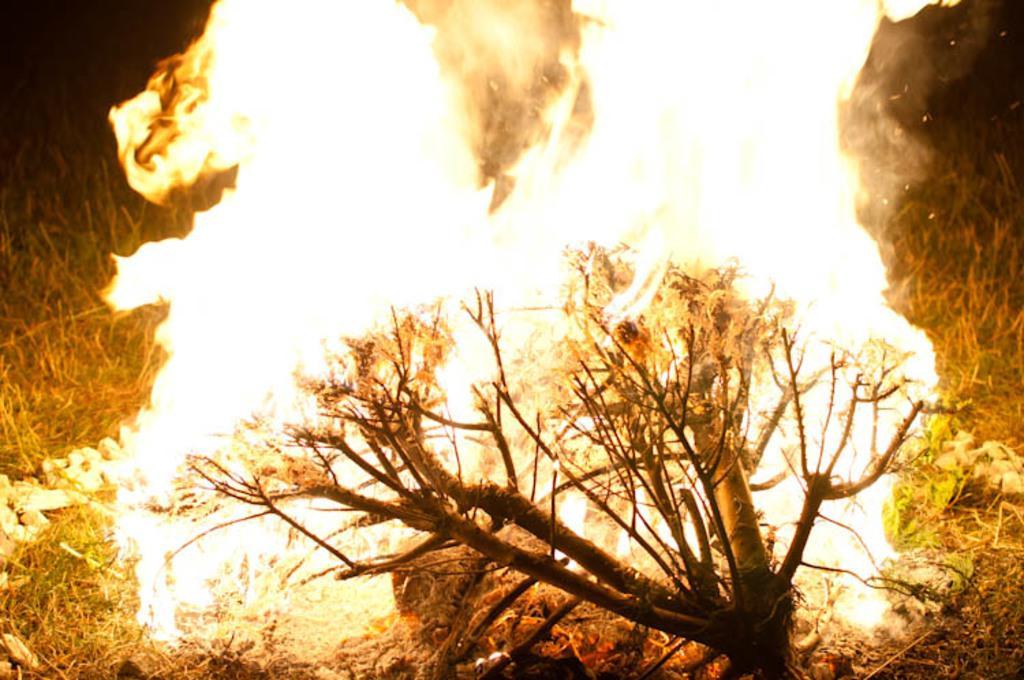Can you describe this image briefly? In the image we can see the flame, tree branch, grass and the background is dark. 